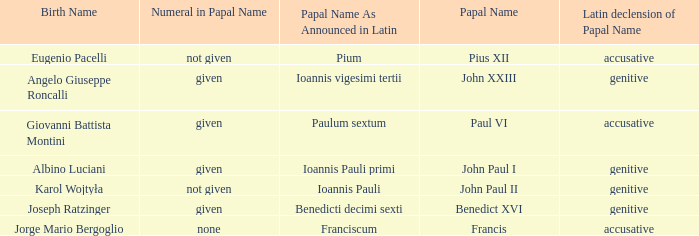For the pope born Eugenio Pacelli, what is the declension of his papal name? Accusative. 